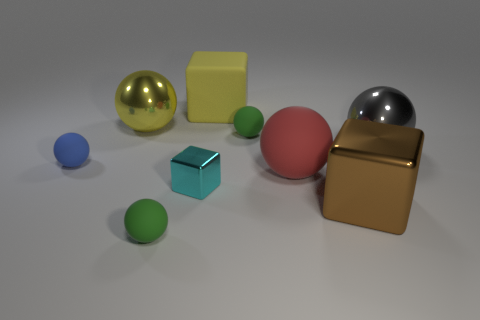There is a shiny ball behind the metal ball that is right of the big matte object that is in front of the big yellow matte thing; how big is it? The shiny ball positioned behind the metal ball appears to be of medium size relative to the other objects in the scene, including the large matte shapes. Its size suggests it may be smaller than the big yellow matte block but larger than the smallest spheres present. 